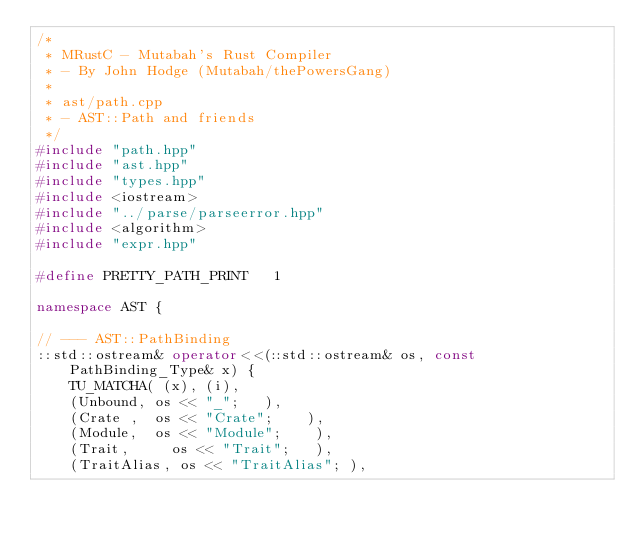Convert code to text. <code><loc_0><loc_0><loc_500><loc_500><_C++_>/*
 * MRustC - Mutabah's Rust Compiler
 * - By John Hodge (Mutabah/thePowersGang)
 *
 * ast/path.cpp
 * - AST::Path and friends
 */
#include "path.hpp"
#include "ast.hpp"
#include "types.hpp"
#include <iostream>
#include "../parse/parseerror.hpp"
#include <algorithm>
#include "expr.hpp"

#define PRETTY_PATH_PRINT   1

namespace AST {

// --- AST::PathBinding
::std::ostream& operator<<(::std::ostream& os, const PathBinding_Type& x) {
    TU_MATCHA( (x), (i),
    (Unbound, os << "_";   ),
    (Crate ,  os << "Crate";    ),
    (Module,  os << "Module";    ),
    (Trait,     os << "Trait";   ),
    (TraitAlias, os << "TraitAlias"; ),</code> 